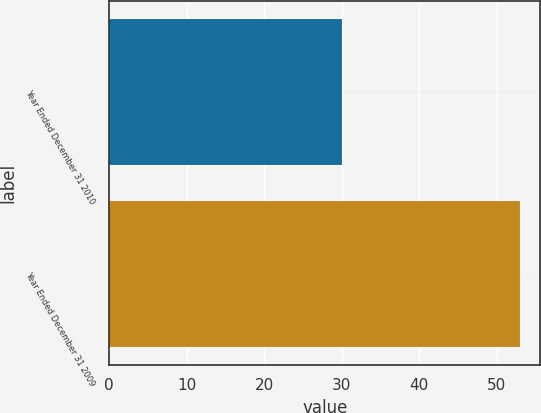<chart> <loc_0><loc_0><loc_500><loc_500><bar_chart><fcel>Year Ended December 31 2010<fcel>Year Ended December 31 2009<nl><fcel>30<fcel>53<nl></chart> 